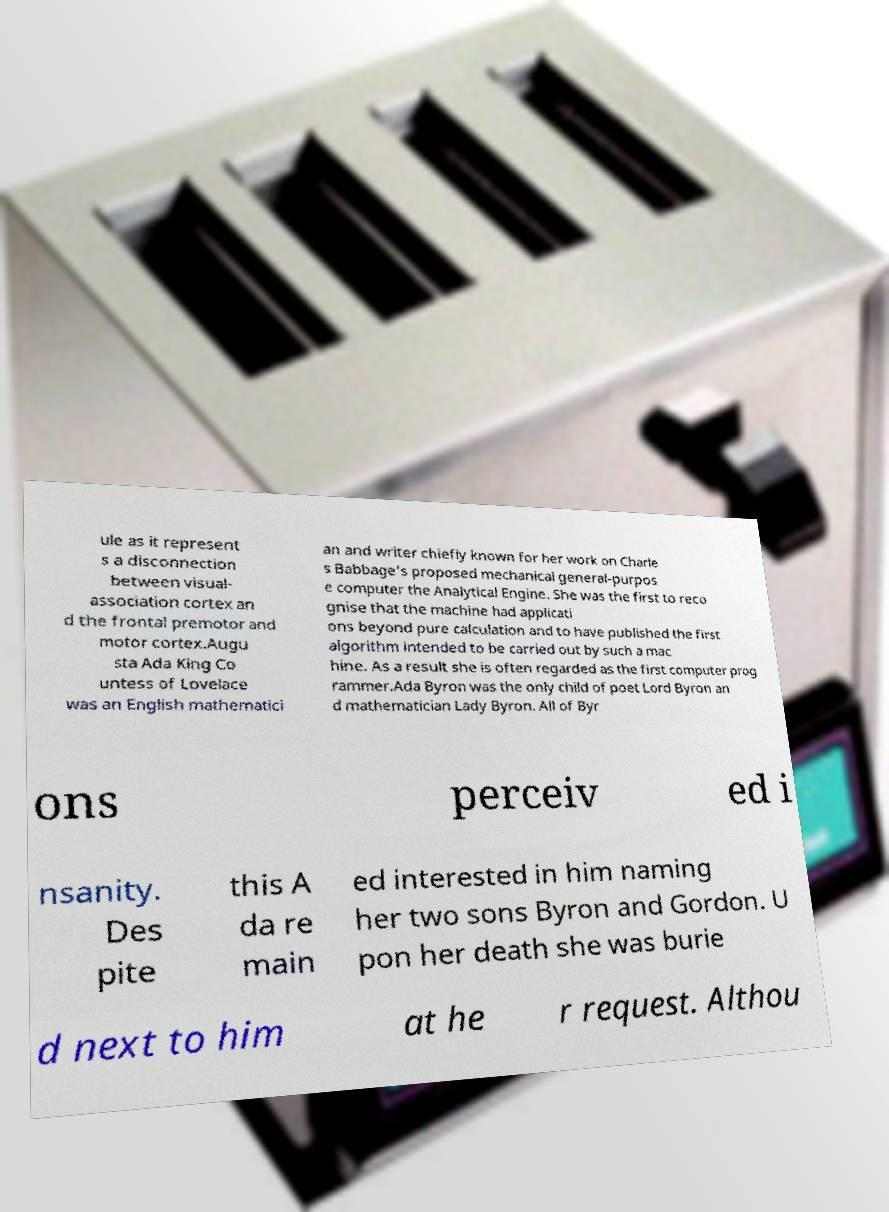There's text embedded in this image that I need extracted. Can you transcribe it verbatim? ule as it represent s a disconnection between visual- association cortex an d the frontal premotor and motor cortex.Augu sta Ada King Co untess of Lovelace was an English mathematici an and writer chiefly known for her work on Charle s Babbage's proposed mechanical general-purpos e computer the Analytical Engine. She was the first to reco gnise that the machine had applicati ons beyond pure calculation and to have published the first algorithm intended to be carried out by such a mac hine. As a result she is often regarded as the first computer prog rammer.Ada Byron was the only child of poet Lord Byron an d mathematician Lady Byron. All of Byr ons perceiv ed i nsanity. Des pite this A da re main ed interested in him naming her two sons Byron and Gordon. U pon her death she was burie d next to him at he r request. Althou 